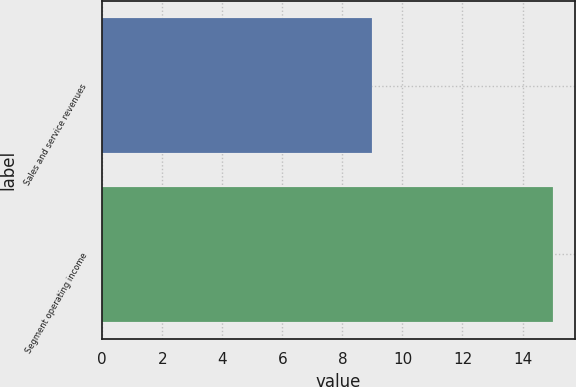<chart> <loc_0><loc_0><loc_500><loc_500><bar_chart><fcel>Sales and service revenues<fcel>Segment operating income<nl><fcel>9<fcel>15<nl></chart> 